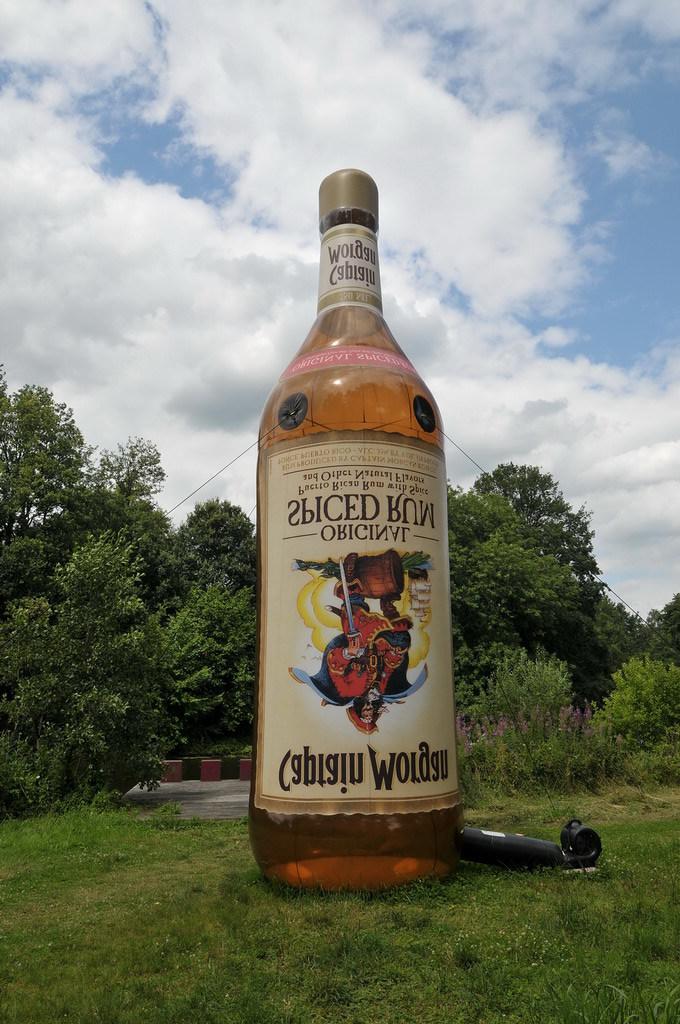What do the black letters read?
Your answer should be compact. Captain morgan. What brand is this?
Make the answer very short. Captain morgan. 